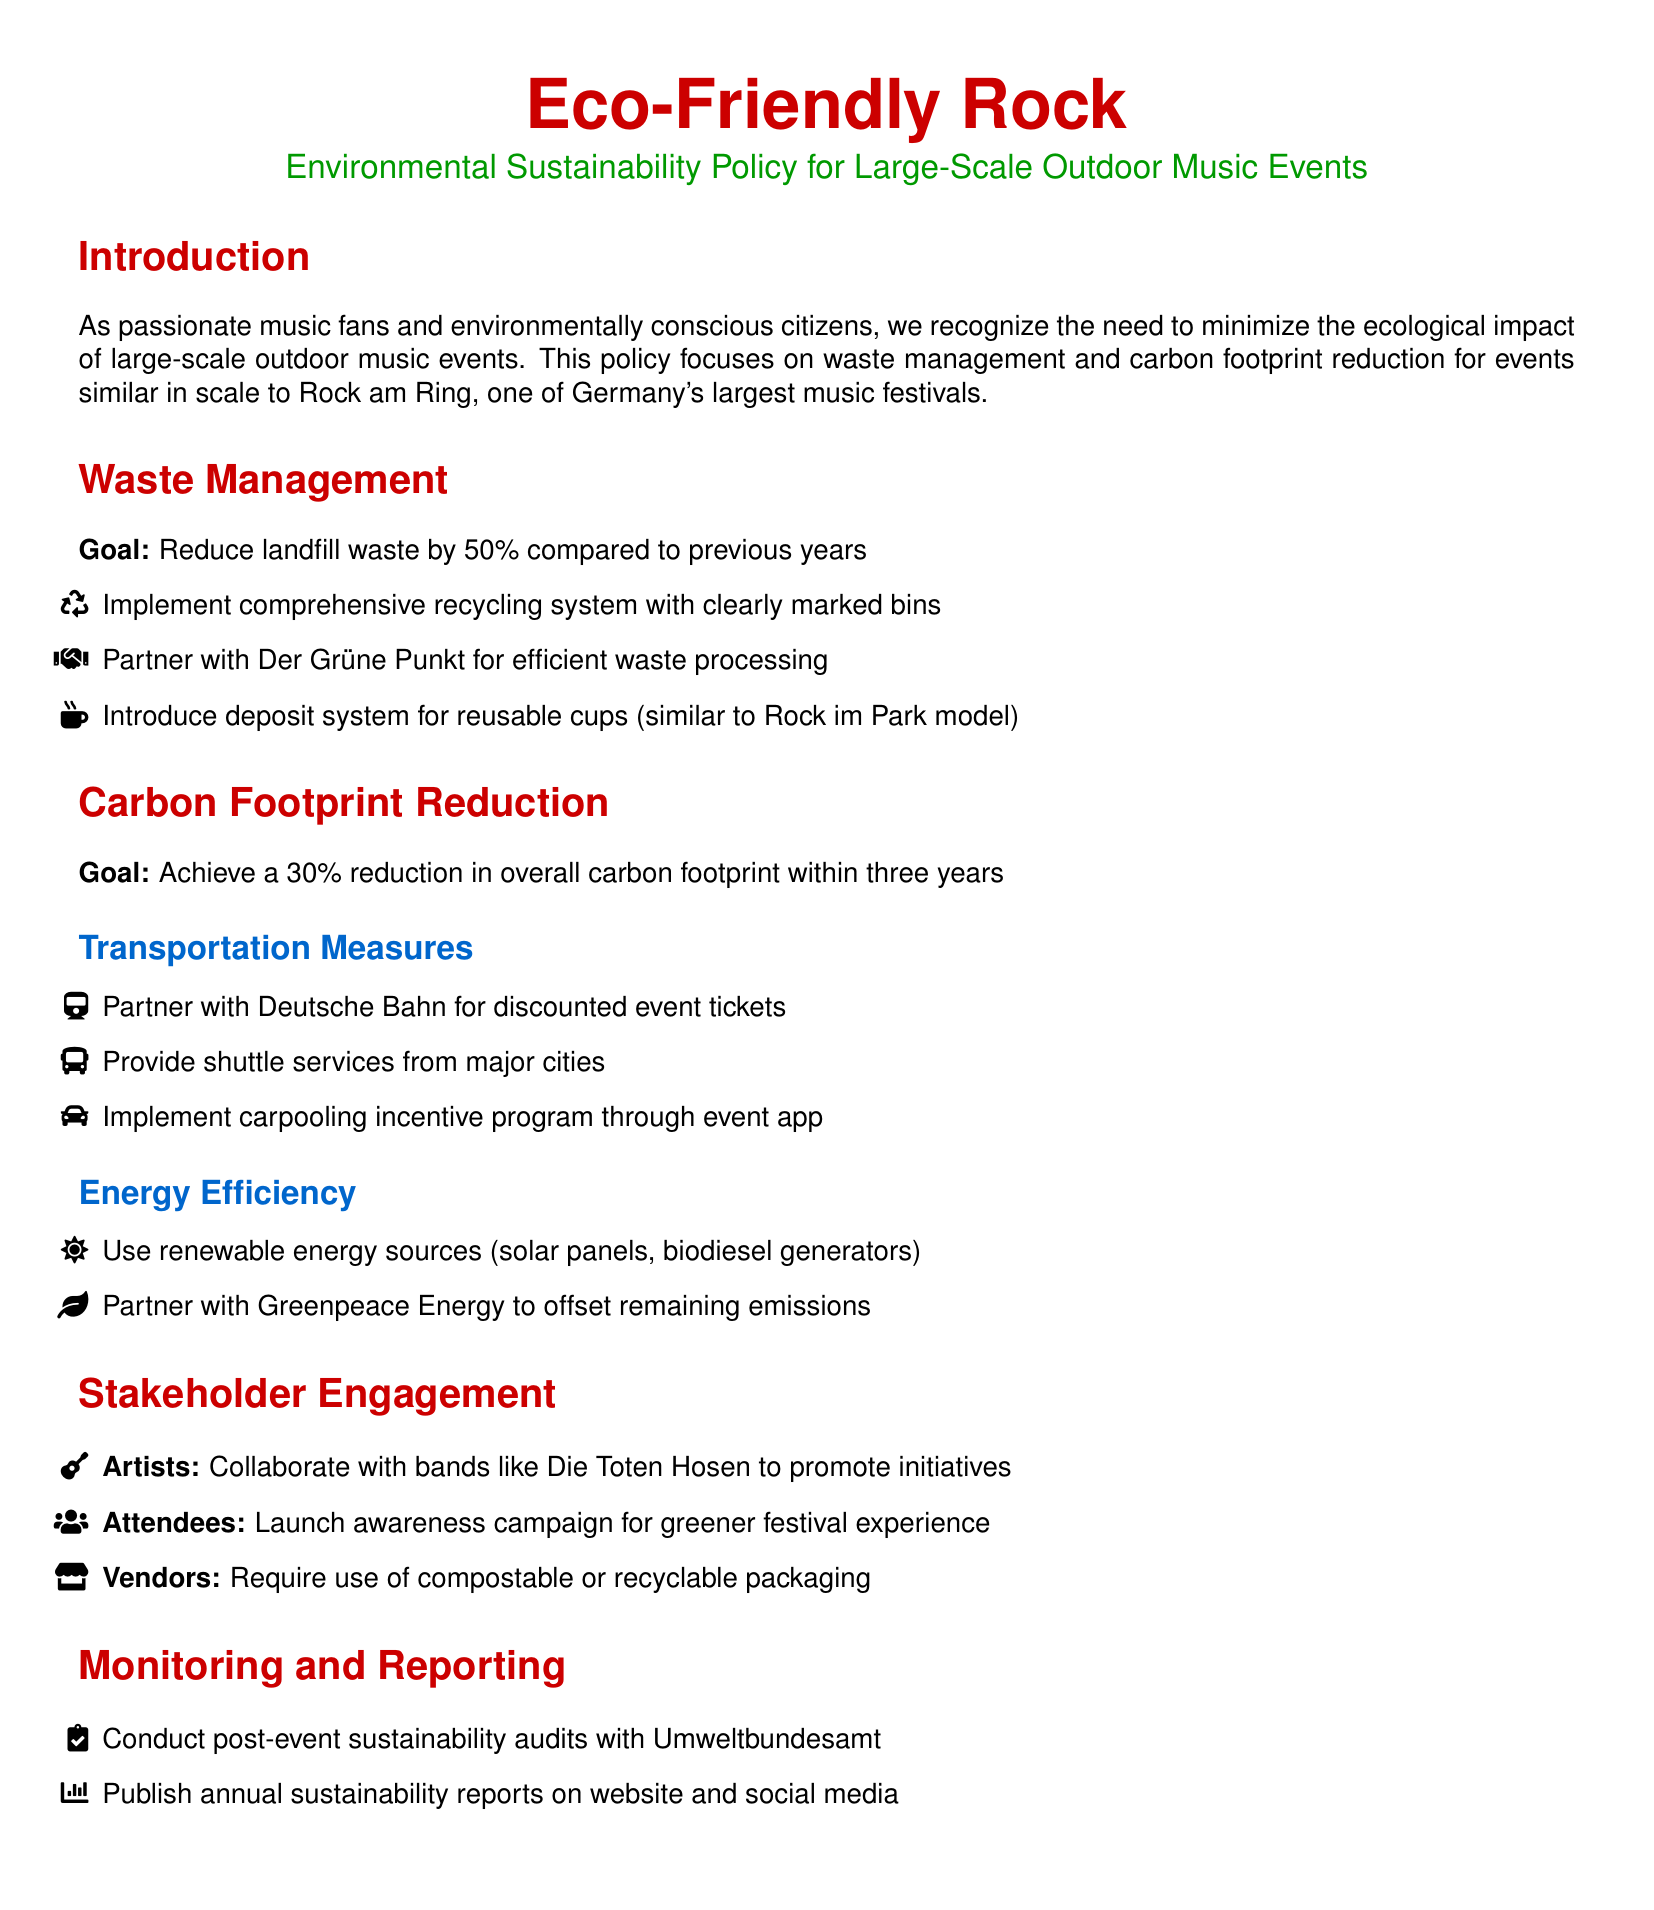What is the goal for waste reduction? The document states the goal is to reduce landfill waste by 50% compared to previous years.
Answer: 50% Which organization is partnered for waste processing? The policy document mentions a partnership with Der Grüne Punkt for efficient waste processing.
Answer: Der Grüne Punkt What is the expected reduction in carbon footprint? The goal stated in the document is to achieve a 30% reduction in overall carbon footprint within three years.
Answer: 30% Which energy sources will be used for events? The document specifies the use of renewable energy sources such as solar panels and biodiesel generators.
Answer: Renewable energy sources Name one transportation measure outlined in the policy. The policy mentions partnering with Deutsche Bahn for discounted event tickets as a transportation measure.
Answer: Deutsche Bahn Who is mentioned as a key stakeholder for collaboration? The document identifies artists, specifically Die Toten Hosen, as a key stakeholder for collaboration to promote initiatives.
Answer: Die Toten Hosen What type of packaging is required for vendors? The document states that vendors are required to use compostable or recyclable packaging.
Answer: Compostable or recyclable packaging How often will sustainability reports be published? The document indicates that annual sustainability reports will be published.
Answer: Annual 